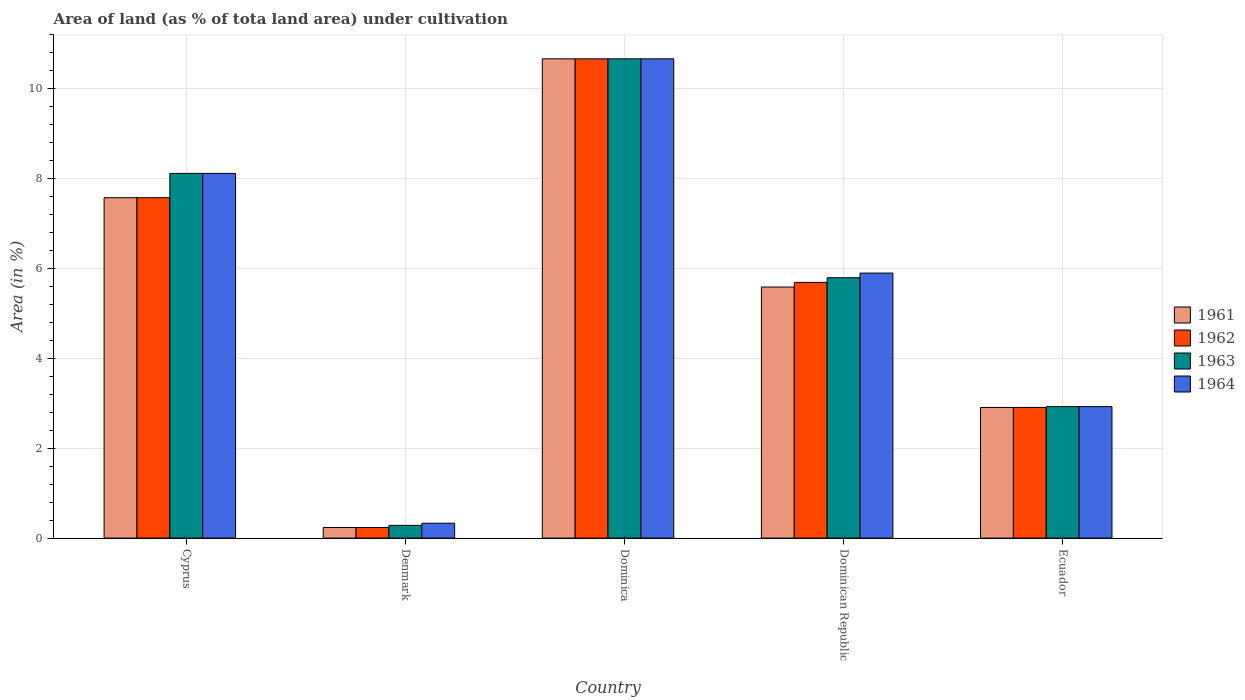How many different coloured bars are there?
Your answer should be compact. 4. Are the number of bars per tick equal to the number of legend labels?
Provide a succinct answer. Yes. How many bars are there on the 3rd tick from the left?
Keep it short and to the point. 4. How many bars are there on the 1st tick from the right?
Offer a terse response. 4. What is the label of the 5th group of bars from the left?
Ensure brevity in your answer.  Ecuador. What is the percentage of land under cultivation in 1963 in Dominican Republic?
Keep it short and to the point. 5.79. Across all countries, what is the maximum percentage of land under cultivation in 1964?
Your response must be concise. 10.67. Across all countries, what is the minimum percentage of land under cultivation in 1961?
Offer a terse response. 0.24. In which country was the percentage of land under cultivation in 1961 maximum?
Offer a very short reply. Dominica. In which country was the percentage of land under cultivation in 1964 minimum?
Offer a terse response. Denmark. What is the total percentage of land under cultivation in 1964 in the graph?
Provide a short and direct response. 27.94. What is the difference between the percentage of land under cultivation in 1962 in Dominica and that in Ecuador?
Give a very brief answer. 7.76. What is the difference between the percentage of land under cultivation in 1964 in Dominica and the percentage of land under cultivation in 1963 in Ecuador?
Keep it short and to the point. 7.74. What is the average percentage of land under cultivation in 1962 per country?
Ensure brevity in your answer.  5.42. What is the ratio of the percentage of land under cultivation in 1962 in Denmark to that in Dominica?
Ensure brevity in your answer.  0.02. Is the difference between the percentage of land under cultivation in 1961 in Denmark and Dominican Republic greater than the difference between the percentage of land under cultivation in 1963 in Denmark and Dominican Republic?
Your answer should be compact. Yes. What is the difference between the highest and the second highest percentage of land under cultivation in 1963?
Give a very brief answer. -2.55. What is the difference between the highest and the lowest percentage of land under cultivation in 1964?
Provide a short and direct response. 10.34. In how many countries, is the percentage of land under cultivation in 1964 greater than the average percentage of land under cultivation in 1964 taken over all countries?
Give a very brief answer. 3. Is it the case that in every country, the sum of the percentage of land under cultivation in 1963 and percentage of land under cultivation in 1961 is greater than the sum of percentage of land under cultivation in 1964 and percentage of land under cultivation in 1962?
Your answer should be compact. No. What does the 3rd bar from the left in Dominican Republic represents?
Offer a very short reply. 1963. What does the 1st bar from the right in Dominica represents?
Your response must be concise. 1964. Is it the case that in every country, the sum of the percentage of land under cultivation in 1962 and percentage of land under cultivation in 1961 is greater than the percentage of land under cultivation in 1964?
Make the answer very short. Yes. Are all the bars in the graph horizontal?
Give a very brief answer. No. What is the difference between two consecutive major ticks on the Y-axis?
Give a very brief answer. 2. Are the values on the major ticks of Y-axis written in scientific E-notation?
Make the answer very short. No. Does the graph contain any zero values?
Your answer should be very brief. No. Where does the legend appear in the graph?
Ensure brevity in your answer.  Center right. How are the legend labels stacked?
Offer a terse response. Vertical. What is the title of the graph?
Provide a succinct answer. Area of land (as % of tota land area) under cultivation. What is the label or title of the X-axis?
Your answer should be very brief. Country. What is the label or title of the Y-axis?
Offer a very short reply. Area (in %). What is the Area (in %) of 1961 in Cyprus?
Provide a short and direct response. 7.58. What is the Area (in %) in 1962 in Cyprus?
Make the answer very short. 7.58. What is the Area (in %) of 1963 in Cyprus?
Make the answer very short. 8.12. What is the Area (in %) in 1964 in Cyprus?
Your response must be concise. 8.12. What is the Area (in %) in 1961 in Denmark?
Give a very brief answer. 0.24. What is the Area (in %) of 1962 in Denmark?
Your response must be concise. 0.24. What is the Area (in %) of 1963 in Denmark?
Your response must be concise. 0.28. What is the Area (in %) of 1964 in Denmark?
Make the answer very short. 0.33. What is the Area (in %) in 1961 in Dominica?
Provide a succinct answer. 10.67. What is the Area (in %) of 1962 in Dominica?
Make the answer very short. 10.67. What is the Area (in %) of 1963 in Dominica?
Make the answer very short. 10.67. What is the Area (in %) in 1964 in Dominica?
Keep it short and to the point. 10.67. What is the Area (in %) of 1961 in Dominican Republic?
Your answer should be very brief. 5.59. What is the Area (in %) in 1962 in Dominican Republic?
Your answer should be very brief. 5.69. What is the Area (in %) in 1963 in Dominican Republic?
Offer a terse response. 5.79. What is the Area (in %) in 1964 in Dominican Republic?
Offer a very short reply. 5.9. What is the Area (in %) of 1961 in Ecuador?
Ensure brevity in your answer.  2.91. What is the Area (in %) of 1962 in Ecuador?
Make the answer very short. 2.91. What is the Area (in %) in 1963 in Ecuador?
Give a very brief answer. 2.93. What is the Area (in %) of 1964 in Ecuador?
Ensure brevity in your answer.  2.93. Across all countries, what is the maximum Area (in %) of 1961?
Offer a very short reply. 10.67. Across all countries, what is the maximum Area (in %) in 1962?
Your answer should be very brief. 10.67. Across all countries, what is the maximum Area (in %) in 1963?
Give a very brief answer. 10.67. Across all countries, what is the maximum Area (in %) in 1964?
Offer a very short reply. 10.67. Across all countries, what is the minimum Area (in %) in 1961?
Offer a very short reply. 0.24. Across all countries, what is the minimum Area (in %) in 1962?
Offer a terse response. 0.24. Across all countries, what is the minimum Area (in %) of 1963?
Ensure brevity in your answer.  0.28. Across all countries, what is the minimum Area (in %) in 1964?
Provide a short and direct response. 0.33. What is the total Area (in %) in 1961 in the graph?
Your response must be concise. 26.97. What is the total Area (in %) of 1962 in the graph?
Your answer should be very brief. 27.08. What is the total Area (in %) of 1963 in the graph?
Give a very brief answer. 27.79. What is the total Area (in %) in 1964 in the graph?
Provide a succinct answer. 27.94. What is the difference between the Area (in %) of 1961 in Cyprus and that in Denmark?
Your answer should be compact. 7.34. What is the difference between the Area (in %) of 1962 in Cyprus and that in Denmark?
Provide a short and direct response. 7.34. What is the difference between the Area (in %) of 1963 in Cyprus and that in Denmark?
Offer a very short reply. 7.83. What is the difference between the Area (in %) in 1964 in Cyprus and that in Denmark?
Make the answer very short. 7.79. What is the difference between the Area (in %) in 1961 in Cyprus and that in Dominica?
Give a very brief answer. -3.09. What is the difference between the Area (in %) of 1962 in Cyprus and that in Dominica?
Your answer should be very brief. -3.09. What is the difference between the Area (in %) in 1963 in Cyprus and that in Dominica?
Provide a succinct answer. -2.55. What is the difference between the Area (in %) of 1964 in Cyprus and that in Dominica?
Provide a short and direct response. -2.55. What is the difference between the Area (in %) of 1961 in Cyprus and that in Dominican Republic?
Your answer should be compact. 1.99. What is the difference between the Area (in %) of 1962 in Cyprus and that in Dominican Republic?
Keep it short and to the point. 1.88. What is the difference between the Area (in %) in 1963 in Cyprus and that in Dominican Republic?
Ensure brevity in your answer.  2.32. What is the difference between the Area (in %) in 1964 in Cyprus and that in Dominican Republic?
Provide a short and direct response. 2.22. What is the difference between the Area (in %) of 1961 in Cyprus and that in Ecuador?
Offer a very short reply. 4.67. What is the difference between the Area (in %) of 1962 in Cyprus and that in Ecuador?
Ensure brevity in your answer.  4.67. What is the difference between the Area (in %) in 1963 in Cyprus and that in Ecuador?
Keep it short and to the point. 5.19. What is the difference between the Area (in %) in 1964 in Cyprus and that in Ecuador?
Give a very brief answer. 5.19. What is the difference between the Area (in %) in 1961 in Denmark and that in Dominica?
Your answer should be very brief. -10.43. What is the difference between the Area (in %) of 1962 in Denmark and that in Dominica?
Give a very brief answer. -10.43. What is the difference between the Area (in %) in 1963 in Denmark and that in Dominica?
Ensure brevity in your answer.  -10.38. What is the difference between the Area (in %) in 1964 in Denmark and that in Dominica?
Your answer should be compact. -10.34. What is the difference between the Area (in %) in 1961 in Denmark and that in Dominican Republic?
Offer a very short reply. -5.35. What is the difference between the Area (in %) in 1962 in Denmark and that in Dominican Republic?
Provide a short and direct response. -5.46. What is the difference between the Area (in %) of 1963 in Denmark and that in Dominican Republic?
Ensure brevity in your answer.  -5.51. What is the difference between the Area (in %) of 1964 in Denmark and that in Dominican Republic?
Give a very brief answer. -5.57. What is the difference between the Area (in %) in 1961 in Denmark and that in Ecuador?
Give a very brief answer. -2.67. What is the difference between the Area (in %) in 1962 in Denmark and that in Ecuador?
Keep it short and to the point. -2.67. What is the difference between the Area (in %) in 1963 in Denmark and that in Ecuador?
Offer a very short reply. -2.64. What is the difference between the Area (in %) in 1964 in Denmark and that in Ecuador?
Your answer should be compact. -2.6. What is the difference between the Area (in %) of 1961 in Dominica and that in Dominican Republic?
Provide a short and direct response. 5.08. What is the difference between the Area (in %) in 1962 in Dominica and that in Dominican Republic?
Provide a succinct answer. 4.98. What is the difference between the Area (in %) of 1963 in Dominica and that in Dominican Republic?
Your answer should be very brief. 4.87. What is the difference between the Area (in %) of 1964 in Dominica and that in Dominican Republic?
Your answer should be compact. 4.77. What is the difference between the Area (in %) of 1961 in Dominica and that in Ecuador?
Your response must be concise. 7.76. What is the difference between the Area (in %) in 1962 in Dominica and that in Ecuador?
Keep it short and to the point. 7.76. What is the difference between the Area (in %) of 1963 in Dominica and that in Ecuador?
Offer a terse response. 7.74. What is the difference between the Area (in %) in 1964 in Dominica and that in Ecuador?
Your answer should be very brief. 7.74. What is the difference between the Area (in %) in 1961 in Dominican Republic and that in Ecuador?
Keep it short and to the point. 2.68. What is the difference between the Area (in %) of 1962 in Dominican Republic and that in Ecuador?
Keep it short and to the point. 2.78. What is the difference between the Area (in %) in 1963 in Dominican Republic and that in Ecuador?
Ensure brevity in your answer.  2.87. What is the difference between the Area (in %) of 1964 in Dominican Republic and that in Ecuador?
Your response must be concise. 2.97. What is the difference between the Area (in %) of 1961 in Cyprus and the Area (in %) of 1962 in Denmark?
Your answer should be very brief. 7.34. What is the difference between the Area (in %) of 1961 in Cyprus and the Area (in %) of 1963 in Denmark?
Provide a succinct answer. 7.29. What is the difference between the Area (in %) in 1961 in Cyprus and the Area (in %) in 1964 in Denmark?
Offer a very short reply. 7.25. What is the difference between the Area (in %) of 1962 in Cyprus and the Area (in %) of 1963 in Denmark?
Your answer should be compact. 7.29. What is the difference between the Area (in %) in 1962 in Cyprus and the Area (in %) in 1964 in Denmark?
Offer a very short reply. 7.25. What is the difference between the Area (in %) of 1963 in Cyprus and the Area (in %) of 1964 in Denmark?
Your answer should be compact. 7.79. What is the difference between the Area (in %) in 1961 in Cyprus and the Area (in %) in 1962 in Dominica?
Make the answer very short. -3.09. What is the difference between the Area (in %) in 1961 in Cyprus and the Area (in %) in 1963 in Dominica?
Give a very brief answer. -3.09. What is the difference between the Area (in %) of 1961 in Cyprus and the Area (in %) of 1964 in Dominica?
Offer a very short reply. -3.09. What is the difference between the Area (in %) of 1962 in Cyprus and the Area (in %) of 1963 in Dominica?
Make the answer very short. -3.09. What is the difference between the Area (in %) in 1962 in Cyprus and the Area (in %) in 1964 in Dominica?
Your response must be concise. -3.09. What is the difference between the Area (in %) of 1963 in Cyprus and the Area (in %) of 1964 in Dominica?
Ensure brevity in your answer.  -2.55. What is the difference between the Area (in %) in 1961 in Cyprus and the Area (in %) in 1962 in Dominican Republic?
Ensure brevity in your answer.  1.88. What is the difference between the Area (in %) in 1961 in Cyprus and the Area (in %) in 1963 in Dominican Republic?
Give a very brief answer. 1.78. What is the difference between the Area (in %) in 1961 in Cyprus and the Area (in %) in 1964 in Dominican Republic?
Provide a succinct answer. 1.68. What is the difference between the Area (in %) in 1962 in Cyprus and the Area (in %) in 1963 in Dominican Republic?
Your answer should be very brief. 1.78. What is the difference between the Area (in %) in 1962 in Cyprus and the Area (in %) in 1964 in Dominican Republic?
Your answer should be compact. 1.68. What is the difference between the Area (in %) in 1963 in Cyprus and the Area (in %) in 1964 in Dominican Republic?
Offer a terse response. 2.22. What is the difference between the Area (in %) in 1961 in Cyprus and the Area (in %) in 1962 in Ecuador?
Your answer should be compact. 4.67. What is the difference between the Area (in %) in 1961 in Cyprus and the Area (in %) in 1963 in Ecuador?
Keep it short and to the point. 4.65. What is the difference between the Area (in %) in 1961 in Cyprus and the Area (in %) in 1964 in Ecuador?
Provide a succinct answer. 4.65. What is the difference between the Area (in %) in 1962 in Cyprus and the Area (in %) in 1963 in Ecuador?
Your answer should be compact. 4.65. What is the difference between the Area (in %) in 1962 in Cyprus and the Area (in %) in 1964 in Ecuador?
Ensure brevity in your answer.  4.65. What is the difference between the Area (in %) of 1963 in Cyprus and the Area (in %) of 1964 in Ecuador?
Keep it short and to the point. 5.19. What is the difference between the Area (in %) of 1961 in Denmark and the Area (in %) of 1962 in Dominica?
Offer a very short reply. -10.43. What is the difference between the Area (in %) in 1961 in Denmark and the Area (in %) in 1963 in Dominica?
Make the answer very short. -10.43. What is the difference between the Area (in %) in 1961 in Denmark and the Area (in %) in 1964 in Dominica?
Offer a very short reply. -10.43. What is the difference between the Area (in %) of 1962 in Denmark and the Area (in %) of 1963 in Dominica?
Offer a terse response. -10.43. What is the difference between the Area (in %) of 1962 in Denmark and the Area (in %) of 1964 in Dominica?
Your answer should be very brief. -10.43. What is the difference between the Area (in %) in 1963 in Denmark and the Area (in %) in 1964 in Dominica?
Your answer should be compact. -10.38. What is the difference between the Area (in %) in 1961 in Denmark and the Area (in %) in 1962 in Dominican Republic?
Keep it short and to the point. -5.46. What is the difference between the Area (in %) in 1961 in Denmark and the Area (in %) in 1963 in Dominican Republic?
Offer a very short reply. -5.56. What is the difference between the Area (in %) of 1961 in Denmark and the Area (in %) of 1964 in Dominican Republic?
Make the answer very short. -5.66. What is the difference between the Area (in %) in 1962 in Denmark and the Area (in %) in 1963 in Dominican Republic?
Make the answer very short. -5.56. What is the difference between the Area (in %) of 1962 in Denmark and the Area (in %) of 1964 in Dominican Republic?
Keep it short and to the point. -5.66. What is the difference between the Area (in %) in 1963 in Denmark and the Area (in %) in 1964 in Dominican Republic?
Your answer should be compact. -5.62. What is the difference between the Area (in %) in 1961 in Denmark and the Area (in %) in 1962 in Ecuador?
Provide a short and direct response. -2.67. What is the difference between the Area (in %) of 1961 in Denmark and the Area (in %) of 1963 in Ecuador?
Ensure brevity in your answer.  -2.69. What is the difference between the Area (in %) in 1961 in Denmark and the Area (in %) in 1964 in Ecuador?
Make the answer very short. -2.69. What is the difference between the Area (in %) in 1962 in Denmark and the Area (in %) in 1963 in Ecuador?
Offer a very short reply. -2.69. What is the difference between the Area (in %) in 1962 in Denmark and the Area (in %) in 1964 in Ecuador?
Keep it short and to the point. -2.69. What is the difference between the Area (in %) of 1963 in Denmark and the Area (in %) of 1964 in Ecuador?
Your answer should be compact. -2.64. What is the difference between the Area (in %) in 1961 in Dominica and the Area (in %) in 1962 in Dominican Republic?
Offer a terse response. 4.98. What is the difference between the Area (in %) of 1961 in Dominica and the Area (in %) of 1963 in Dominican Republic?
Provide a succinct answer. 4.87. What is the difference between the Area (in %) in 1961 in Dominica and the Area (in %) in 1964 in Dominican Republic?
Your response must be concise. 4.77. What is the difference between the Area (in %) in 1962 in Dominica and the Area (in %) in 1963 in Dominican Republic?
Offer a terse response. 4.87. What is the difference between the Area (in %) of 1962 in Dominica and the Area (in %) of 1964 in Dominican Republic?
Provide a short and direct response. 4.77. What is the difference between the Area (in %) in 1963 in Dominica and the Area (in %) in 1964 in Dominican Republic?
Your answer should be compact. 4.77. What is the difference between the Area (in %) of 1961 in Dominica and the Area (in %) of 1962 in Ecuador?
Provide a short and direct response. 7.76. What is the difference between the Area (in %) of 1961 in Dominica and the Area (in %) of 1963 in Ecuador?
Provide a short and direct response. 7.74. What is the difference between the Area (in %) of 1961 in Dominica and the Area (in %) of 1964 in Ecuador?
Your answer should be very brief. 7.74. What is the difference between the Area (in %) in 1962 in Dominica and the Area (in %) in 1963 in Ecuador?
Ensure brevity in your answer.  7.74. What is the difference between the Area (in %) in 1962 in Dominica and the Area (in %) in 1964 in Ecuador?
Give a very brief answer. 7.74. What is the difference between the Area (in %) of 1963 in Dominica and the Area (in %) of 1964 in Ecuador?
Your response must be concise. 7.74. What is the difference between the Area (in %) in 1961 in Dominican Republic and the Area (in %) in 1962 in Ecuador?
Ensure brevity in your answer.  2.68. What is the difference between the Area (in %) of 1961 in Dominican Republic and the Area (in %) of 1963 in Ecuador?
Offer a terse response. 2.66. What is the difference between the Area (in %) in 1961 in Dominican Republic and the Area (in %) in 1964 in Ecuador?
Give a very brief answer. 2.66. What is the difference between the Area (in %) of 1962 in Dominican Republic and the Area (in %) of 1963 in Ecuador?
Keep it short and to the point. 2.77. What is the difference between the Area (in %) in 1962 in Dominican Republic and the Area (in %) in 1964 in Ecuador?
Give a very brief answer. 2.77. What is the difference between the Area (in %) of 1963 in Dominican Republic and the Area (in %) of 1964 in Ecuador?
Make the answer very short. 2.87. What is the average Area (in %) of 1961 per country?
Offer a terse response. 5.39. What is the average Area (in %) of 1962 per country?
Provide a short and direct response. 5.42. What is the average Area (in %) in 1963 per country?
Offer a terse response. 5.56. What is the average Area (in %) of 1964 per country?
Offer a very short reply. 5.59. What is the difference between the Area (in %) in 1961 and Area (in %) in 1962 in Cyprus?
Offer a terse response. 0. What is the difference between the Area (in %) in 1961 and Area (in %) in 1963 in Cyprus?
Your answer should be very brief. -0.54. What is the difference between the Area (in %) of 1961 and Area (in %) of 1964 in Cyprus?
Offer a terse response. -0.54. What is the difference between the Area (in %) of 1962 and Area (in %) of 1963 in Cyprus?
Offer a terse response. -0.54. What is the difference between the Area (in %) of 1962 and Area (in %) of 1964 in Cyprus?
Keep it short and to the point. -0.54. What is the difference between the Area (in %) of 1963 and Area (in %) of 1964 in Cyprus?
Provide a succinct answer. 0. What is the difference between the Area (in %) of 1961 and Area (in %) of 1962 in Denmark?
Offer a terse response. 0. What is the difference between the Area (in %) in 1961 and Area (in %) in 1963 in Denmark?
Offer a very short reply. -0.05. What is the difference between the Area (in %) in 1961 and Area (in %) in 1964 in Denmark?
Give a very brief answer. -0.09. What is the difference between the Area (in %) of 1962 and Area (in %) of 1963 in Denmark?
Provide a short and direct response. -0.05. What is the difference between the Area (in %) in 1962 and Area (in %) in 1964 in Denmark?
Provide a succinct answer. -0.09. What is the difference between the Area (in %) in 1963 and Area (in %) in 1964 in Denmark?
Give a very brief answer. -0.05. What is the difference between the Area (in %) of 1961 and Area (in %) of 1962 in Dominica?
Your answer should be very brief. 0. What is the difference between the Area (in %) in 1962 and Area (in %) in 1963 in Dominica?
Your answer should be very brief. 0. What is the difference between the Area (in %) in 1963 and Area (in %) in 1964 in Dominica?
Offer a terse response. 0. What is the difference between the Area (in %) in 1961 and Area (in %) in 1962 in Dominican Republic?
Provide a short and direct response. -0.1. What is the difference between the Area (in %) of 1961 and Area (in %) of 1963 in Dominican Republic?
Make the answer very short. -0.21. What is the difference between the Area (in %) of 1961 and Area (in %) of 1964 in Dominican Republic?
Keep it short and to the point. -0.31. What is the difference between the Area (in %) in 1962 and Area (in %) in 1963 in Dominican Republic?
Offer a terse response. -0.1. What is the difference between the Area (in %) in 1962 and Area (in %) in 1964 in Dominican Republic?
Offer a very short reply. -0.21. What is the difference between the Area (in %) of 1963 and Area (in %) of 1964 in Dominican Republic?
Make the answer very short. -0.1. What is the difference between the Area (in %) in 1961 and Area (in %) in 1963 in Ecuador?
Give a very brief answer. -0.02. What is the difference between the Area (in %) in 1961 and Area (in %) in 1964 in Ecuador?
Keep it short and to the point. -0.02. What is the difference between the Area (in %) in 1962 and Area (in %) in 1963 in Ecuador?
Offer a very short reply. -0.02. What is the difference between the Area (in %) of 1962 and Area (in %) of 1964 in Ecuador?
Your response must be concise. -0.02. What is the ratio of the Area (in %) in 1961 in Cyprus to that in Denmark?
Give a very brief answer. 32.1. What is the ratio of the Area (in %) of 1962 in Cyprus to that in Denmark?
Provide a short and direct response. 32.1. What is the ratio of the Area (in %) in 1963 in Cyprus to that in Denmark?
Ensure brevity in your answer.  28.66. What is the ratio of the Area (in %) in 1964 in Cyprus to that in Denmark?
Your answer should be compact. 24.57. What is the ratio of the Area (in %) of 1961 in Cyprus to that in Dominica?
Your response must be concise. 0.71. What is the ratio of the Area (in %) of 1962 in Cyprus to that in Dominica?
Keep it short and to the point. 0.71. What is the ratio of the Area (in %) of 1963 in Cyprus to that in Dominica?
Give a very brief answer. 0.76. What is the ratio of the Area (in %) of 1964 in Cyprus to that in Dominica?
Give a very brief answer. 0.76. What is the ratio of the Area (in %) of 1961 in Cyprus to that in Dominican Republic?
Your answer should be compact. 1.36. What is the ratio of the Area (in %) in 1962 in Cyprus to that in Dominican Republic?
Give a very brief answer. 1.33. What is the ratio of the Area (in %) of 1963 in Cyprus to that in Dominican Republic?
Offer a terse response. 1.4. What is the ratio of the Area (in %) of 1964 in Cyprus to that in Dominican Republic?
Make the answer very short. 1.38. What is the ratio of the Area (in %) of 1961 in Cyprus to that in Ecuador?
Ensure brevity in your answer.  2.61. What is the ratio of the Area (in %) in 1962 in Cyprus to that in Ecuador?
Your answer should be very brief. 2.61. What is the ratio of the Area (in %) in 1963 in Cyprus to that in Ecuador?
Keep it short and to the point. 2.77. What is the ratio of the Area (in %) of 1964 in Cyprus to that in Ecuador?
Provide a short and direct response. 2.77. What is the ratio of the Area (in %) of 1961 in Denmark to that in Dominica?
Your answer should be very brief. 0.02. What is the ratio of the Area (in %) of 1962 in Denmark to that in Dominica?
Your answer should be very brief. 0.02. What is the ratio of the Area (in %) in 1963 in Denmark to that in Dominica?
Offer a very short reply. 0.03. What is the ratio of the Area (in %) of 1964 in Denmark to that in Dominica?
Make the answer very short. 0.03. What is the ratio of the Area (in %) of 1961 in Denmark to that in Dominican Republic?
Your answer should be compact. 0.04. What is the ratio of the Area (in %) in 1962 in Denmark to that in Dominican Republic?
Give a very brief answer. 0.04. What is the ratio of the Area (in %) in 1963 in Denmark to that in Dominican Republic?
Offer a very short reply. 0.05. What is the ratio of the Area (in %) of 1964 in Denmark to that in Dominican Republic?
Make the answer very short. 0.06. What is the ratio of the Area (in %) in 1961 in Denmark to that in Ecuador?
Provide a succinct answer. 0.08. What is the ratio of the Area (in %) in 1962 in Denmark to that in Ecuador?
Give a very brief answer. 0.08. What is the ratio of the Area (in %) of 1963 in Denmark to that in Ecuador?
Make the answer very short. 0.1. What is the ratio of the Area (in %) in 1964 in Denmark to that in Ecuador?
Keep it short and to the point. 0.11. What is the ratio of the Area (in %) in 1961 in Dominica to that in Dominican Republic?
Ensure brevity in your answer.  1.91. What is the ratio of the Area (in %) of 1962 in Dominica to that in Dominican Republic?
Your response must be concise. 1.87. What is the ratio of the Area (in %) of 1963 in Dominica to that in Dominican Republic?
Your response must be concise. 1.84. What is the ratio of the Area (in %) of 1964 in Dominica to that in Dominican Republic?
Your response must be concise. 1.81. What is the ratio of the Area (in %) of 1961 in Dominica to that in Ecuador?
Your answer should be compact. 3.67. What is the ratio of the Area (in %) in 1962 in Dominica to that in Ecuador?
Offer a very short reply. 3.67. What is the ratio of the Area (in %) in 1963 in Dominica to that in Ecuador?
Provide a short and direct response. 3.65. What is the ratio of the Area (in %) in 1964 in Dominica to that in Ecuador?
Your response must be concise. 3.65. What is the ratio of the Area (in %) of 1961 in Dominican Republic to that in Ecuador?
Provide a succinct answer. 1.92. What is the ratio of the Area (in %) in 1962 in Dominican Republic to that in Ecuador?
Make the answer very short. 1.96. What is the ratio of the Area (in %) of 1963 in Dominican Republic to that in Ecuador?
Provide a short and direct response. 1.98. What is the ratio of the Area (in %) in 1964 in Dominican Republic to that in Ecuador?
Make the answer very short. 2.02. What is the difference between the highest and the second highest Area (in %) in 1961?
Offer a very short reply. 3.09. What is the difference between the highest and the second highest Area (in %) of 1962?
Ensure brevity in your answer.  3.09. What is the difference between the highest and the second highest Area (in %) of 1963?
Provide a short and direct response. 2.55. What is the difference between the highest and the second highest Area (in %) in 1964?
Give a very brief answer. 2.55. What is the difference between the highest and the lowest Area (in %) in 1961?
Make the answer very short. 10.43. What is the difference between the highest and the lowest Area (in %) of 1962?
Offer a terse response. 10.43. What is the difference between the highest and the lowest Area (in %) in 1963?
Offer a terse response. 10.38. What is the difference between the highest and the lowest Area (in %) in 1964?
Make the answer very short. 10.34. 